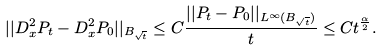Convert formula to latex. <formula><loc_0><loc_0><loc_500><loc_500>| | D _ { x } ^ { 2 } P _ { t } - D _ { x } ^ { 2 } P _ { 0 } | | _ { B _ { \sqrt { t } } } \leq C \frac { | | P _ { t } - P _ { 0 } | | _ { L ^ { \infty } ( B _ { \sqrt { t } } ) } } { t } \leq C t ^ { \frac { \alpha } { 2 } } .</formula> 